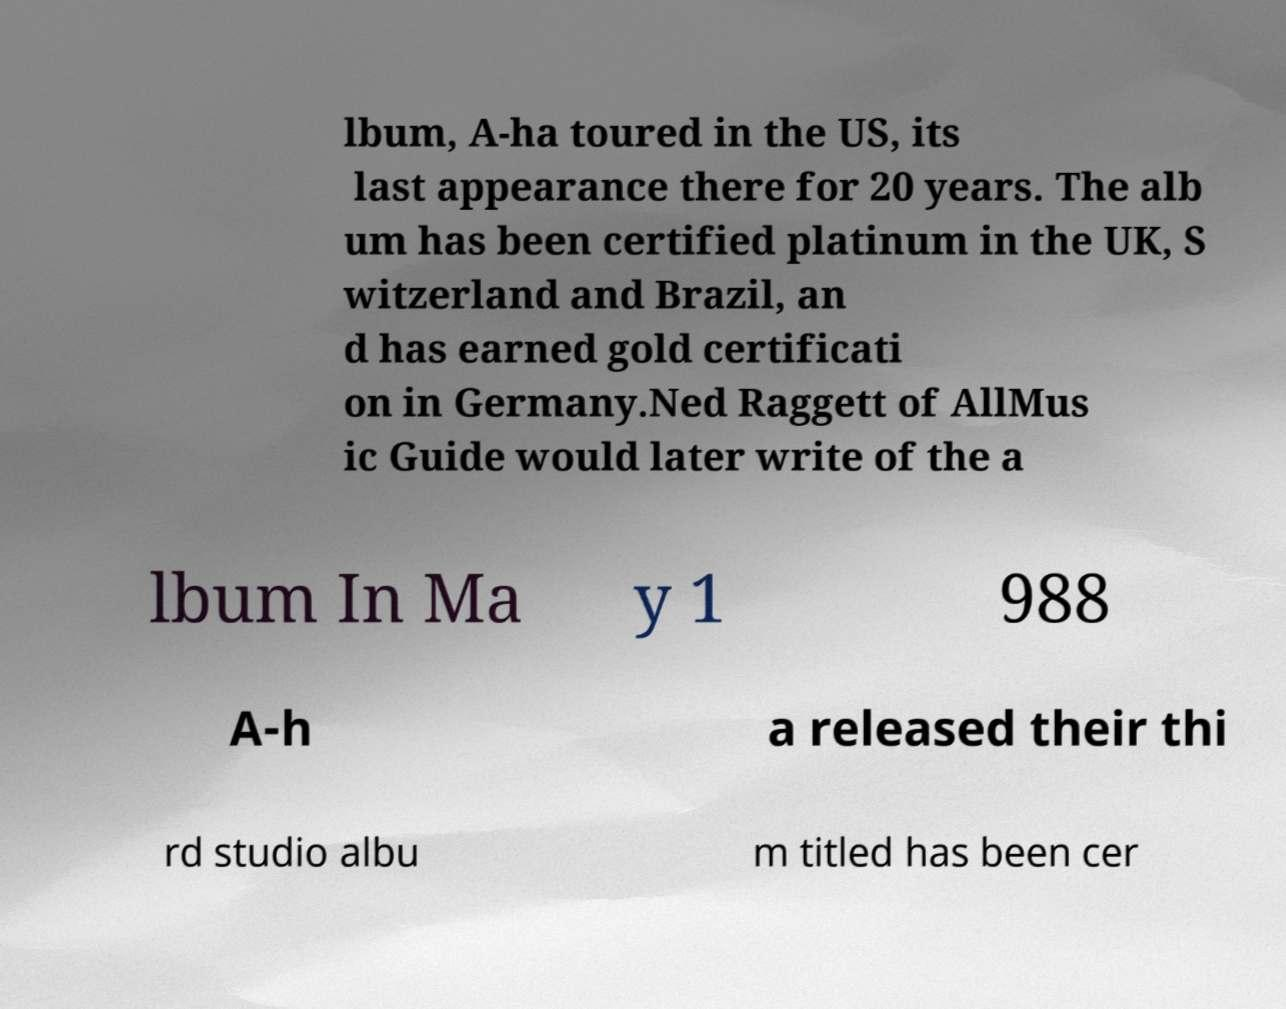For documentation purposes, I need the text within this image transcribed. Could you provide that? lbum, A-ha toured in the US, its last appearance there for 20 years. The alb um has been certified platinum in the UK, S witzerland and Brazil, an d has earned gold certificati on in Germany.Ned Raggett of AllMus ic Guide would later write of the a lbum In Ma y 1 988 A-h a released their thi rd studio albu m titled has been cer 